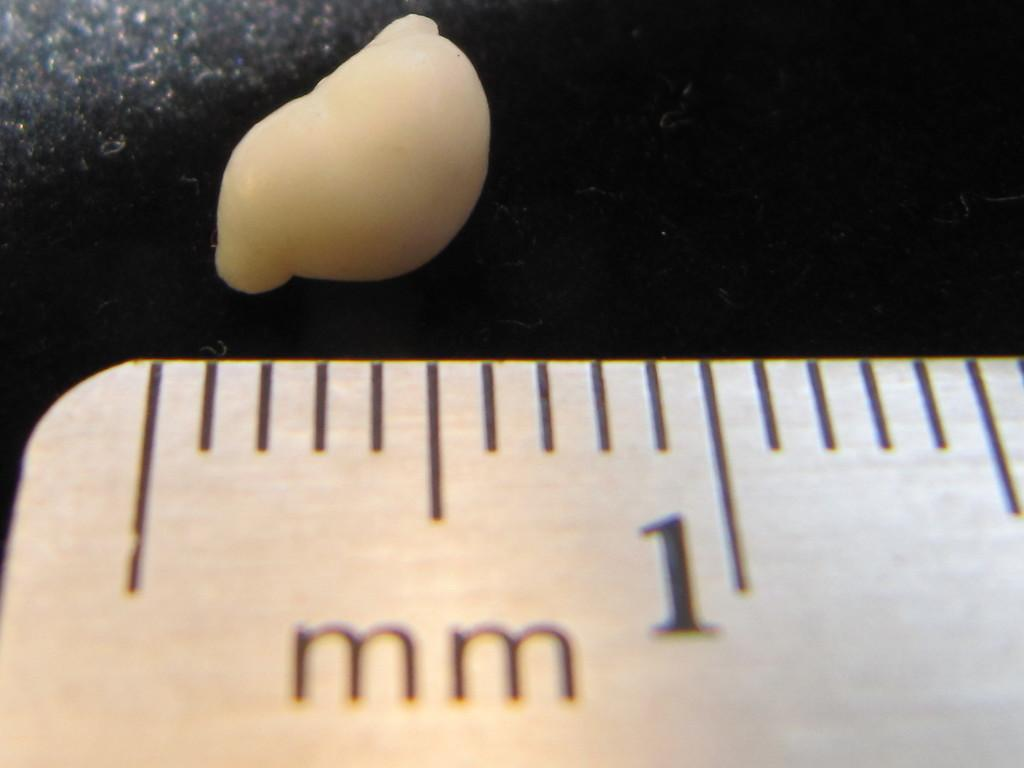<image>
Provide a brief description of the given image. the white thing is being measured by a mm ruler 